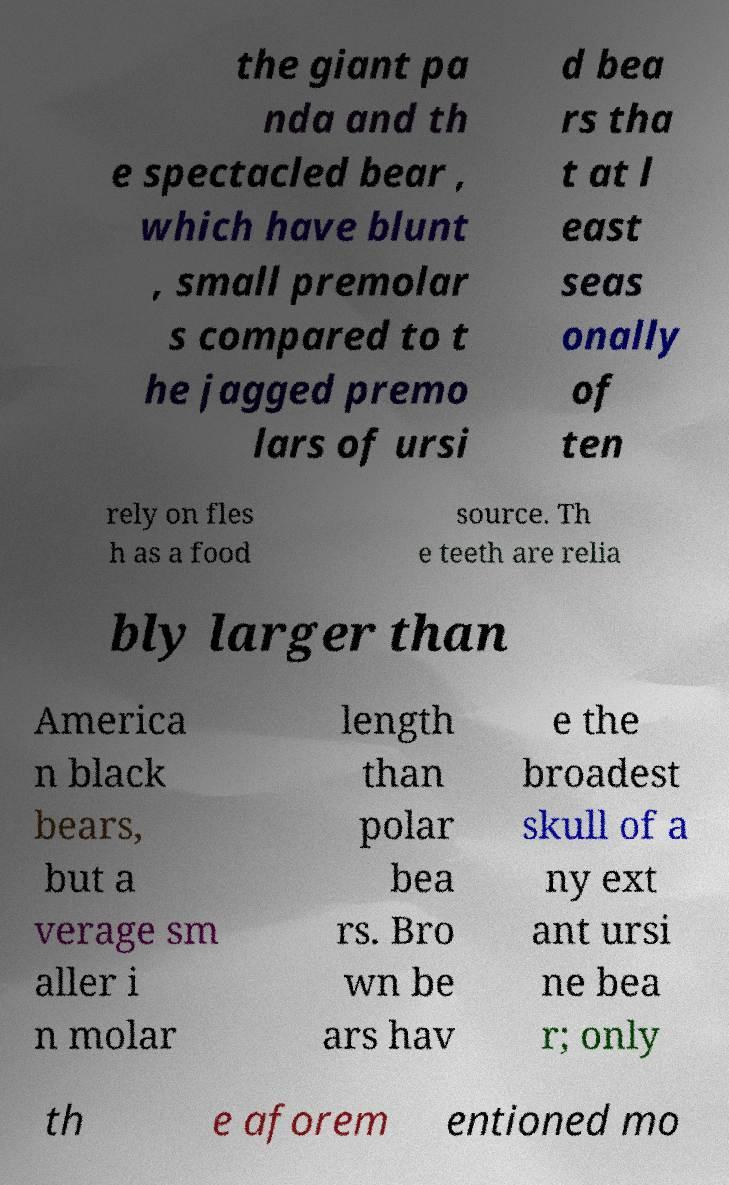I need the written content from this picture converted into text. Can you do that? the giant pa nda and th e spectacled bear , which have blunt , small premolar s compared to t he jagged premo lars of ursi d bea rs tha t at l east seas onally of ten rely on fles h as a food source. Th e teeth are relia bly larger than America n black bears, but a verage sm aller i n molar length than polar bea rs. Bro wn be ars hav e the broadest skull of a ny ext ant ursi ne bea r; only th e aforem entioned mo 